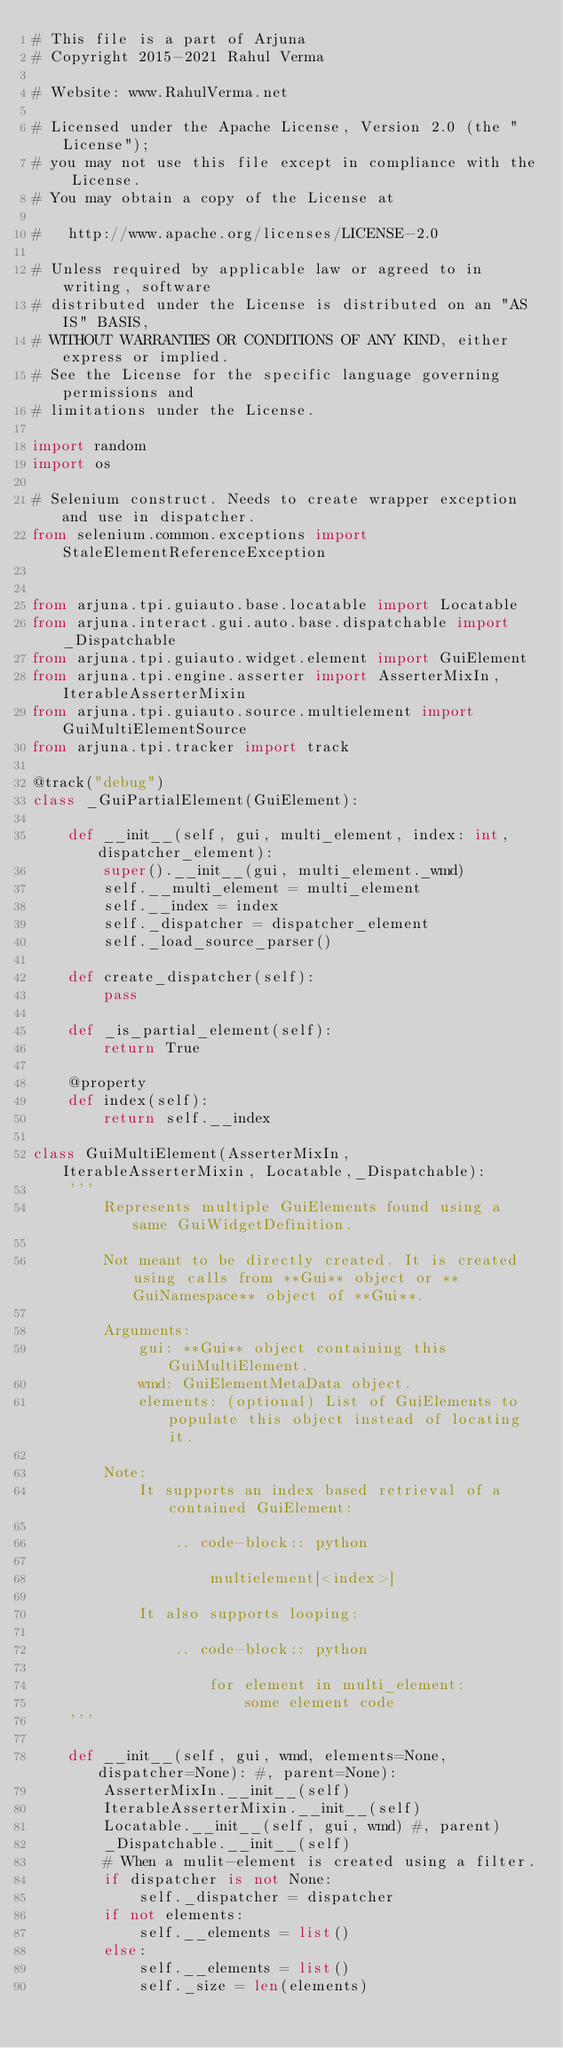Convert code to text. <code><loc_0><loc_0><loc_500><loc_500><_Python_># This file is a part of Arjuna
# Copyright 2015-2021 Rahul Verma

# Website: www.RahulVerma.net

# Licensed under the Apache License, Version 2.0 (the "License");
# you may not use this file except in compliance with the License.
# You may obtain a copy of the License at

#   http://www.apache.org/licenses/LICENSE-2.0

# Unless required by applicable law or agreed to in writing, software
# distributed under the License is distributed on an "AS IS" BASIS,
# WITHOUT WARRANTIES OR CONDITIONS OF ANY KIND, either express or implied.
# See the License for the specific language governing permissions and
# limitations under the License.

import random
import os

# Selenium construct. Needs to create wrapper exception and use in dispatcher.
from selenium.common.exceptions import StaleElementReferenceException


from arjuna.tpi.guiauto.base.locatable import Locatable
from arjuna.interact.gui.auto.base.dispatchable import _Dispatchable
from arjuna.tpi.guiauto.widget.element import GuiElement
from arjuna.tpi.engine.asserter import AsserterMixIn, IterableAsserterMixin
from arjuna.tpi.guiauto.source.multielement import GuiMultiElementSource
from arjuna.tpi.tracker import track

@track("debug")
class _GuiPartialElement(GuiElement):

    def __init__(self, gui, multi_element, index: int, dispatcher_element):
        super().__init__(gui, multi_element._wmd)
        self.__multi_element = multi_element
        self.__index = index
        self._dispatcher = dispatcher_element
        self._load_source_parser()

    def create_dispatcher(self):
        pass

    def _is_partial_element(self):
        return True

    @property
    def index(self):
        return self.__index

class GuiMultiElement(AsserterMixIn, IterableAsserterMixin, Locatable,_Dispatchable):
    '''
        Represents multiple GuiElements found using a same GuiWidgetDefinition.

        Not meant to be directly created. It is created using calls from **Gui** object or **GuiNamespace** object of **Gui**.

        Arguments:
            gui: **Gui** object containing this GuiMultiElement.
            wmd: GuiElementMetaData object.
            elements: (optional) List of GuiElements to populate this object instead of locating it.

        Note:
            It supports an index based retrieval of a contained GuiElement:

                .. code-block:: python

                    multielement[<index>]

            It also supports looping:

                .. code-block:: python

                    for element in multi_element:
                        some element code
    '''
    
    def __init__(self, gui, wmd, elements=None, dispatcher=None): #, parent=None):
        AsserterMixIn.__init__(self)
        IterableAsserterMixin.__init__(self)
        Locatable.__init__(self, gui, wmd) #, parent)
        _Dispatchable.__init__(self)
        # When a mulit-element is created using a filter.
        if dispatcher is not None:
            self._dispatcher = dispatcher
        if not elements:
            self.__elements = list()
        else:
            self.__elements = list()
            self._size = len(elements)
</code> 